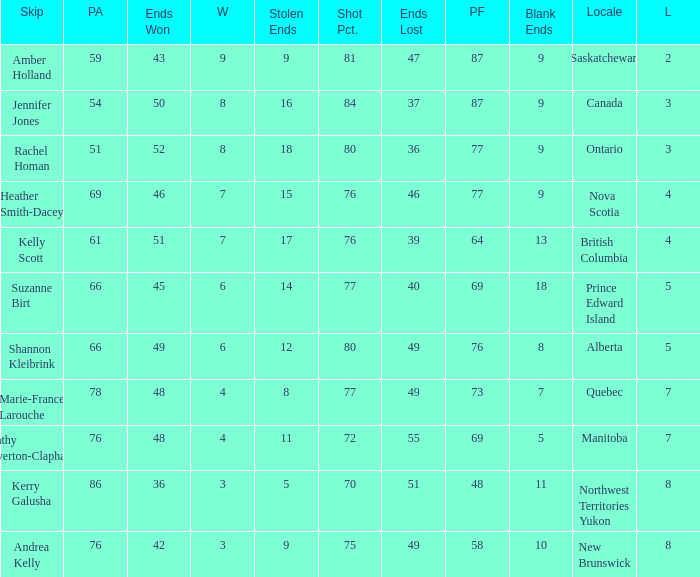If the locale is Ontario, what is the W minimum? 8.0. 